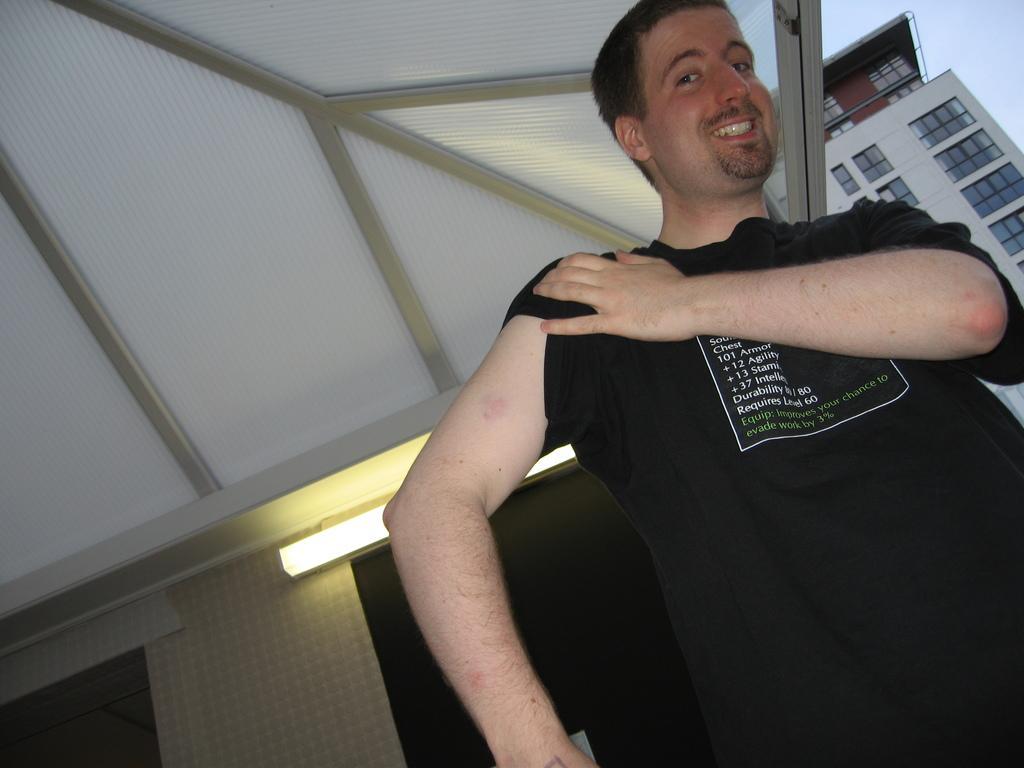Can you describe this image briefly? There is one person standing on the right side is wearing a black color t shirt. There is a wall in the background. There is a light as we can see in the middle of this image, and there is a building at the top right corner of this image. 